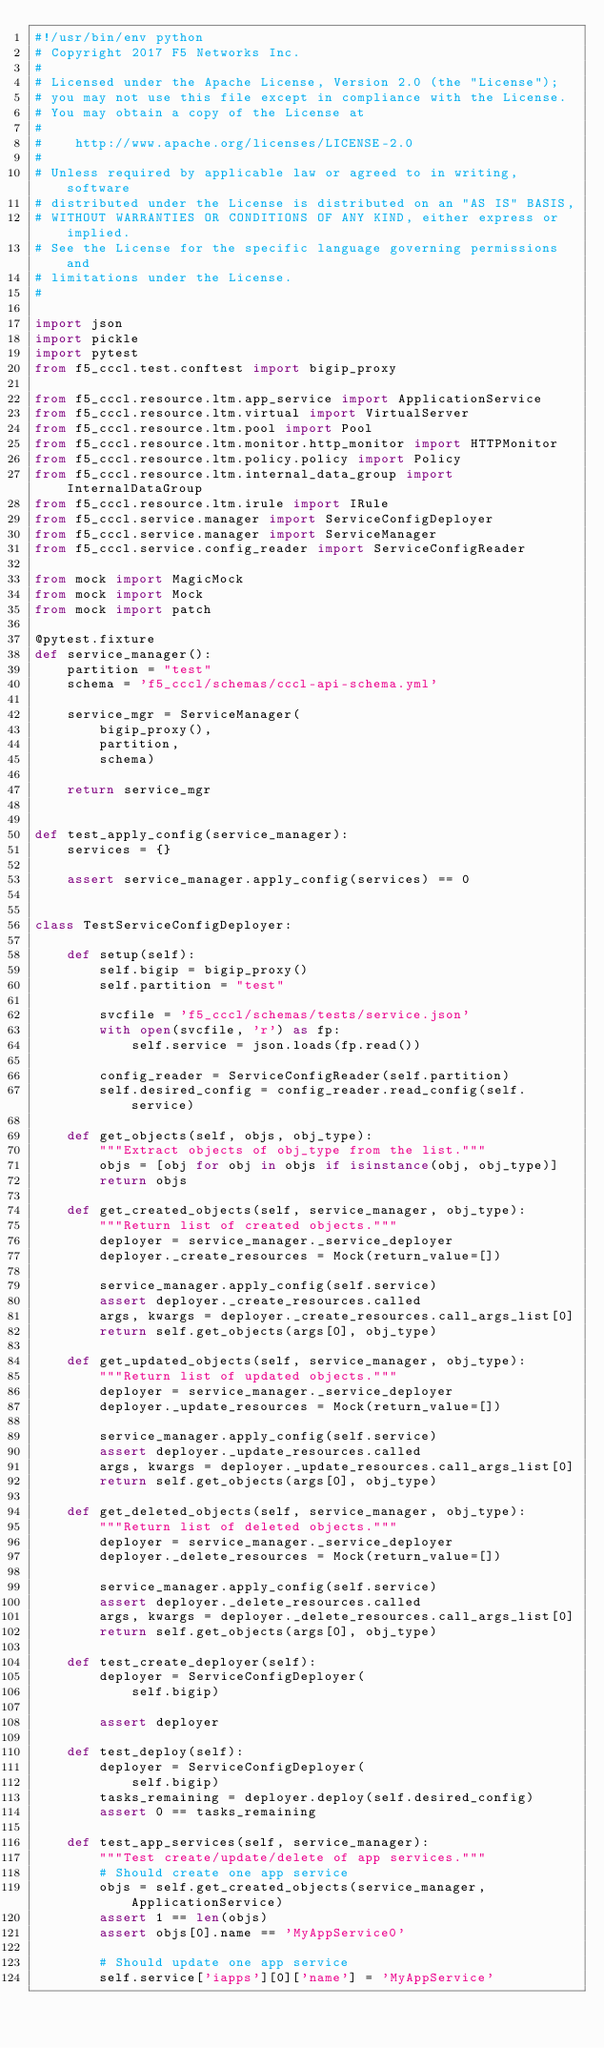Convert code to text. <code><loc_0><loc_0><loc_500><loc_500><_Python_>#!/usr/bin/env python
# Copyright 2017 F5 Networks Inc.
#
# Licensed under the Apache License, Version 2.0 (the "License");
# you may not use this file except in compliance with the License.
# You may obtain a copy of the License at
#
#    http://www.apache.org/licenses/LICENSE-2.0
#
# Unless required by applicable law or agreed to in writing, software
# distributed under the License is distributed on an "AS IS" BASIS,
# WITHOUT WARRANTIES OR CONDITIONS OF ANY KIND, either express or implied.
# See the License for the specific language governing permissions and
# limitations under the License.
#

import json
import pickle
import pytest
from f5_cccl.test.conftest import bigip_proxy

from f5_cccl.resource.ltm.app_service import ApplicationService 
from f5_cccl.resource.ltm.virtual import VirtualServer 
from f5_cccl.resource.ltm.pool import Pool 
from f5_cccl.resource.ltm.monitor.http_monitor import HTTPMonitor 
from f5_cccl.resource.ltm.policy.policy import Policy 
from f5_cccl.resource.ltm.internal_data_group import InternalDataGroup
from f5_cccl.resource.ltm.irule import IRule
from f5_cccl.service.manager import ServiceConfigDeployer
from f5_cccl.service.manager import ServiceManager
from f5_cccl.service.config_reader import ServiceConfigReader

from mock import MagicMock
from mock import Mock
from mock import patch

@pytest.fixture
def service_manager():
    partition = "test"
    schema = 'f5_cccl/schemas/cccl-api-schema.yml'

    service_mgr = ServiceManager(
        bigip_proxy(),
        partition,
        schema)

    return service_mgr


def test_apply_config(service_manager):
    services = {}

    assert service_manager.apply_config(services) == 0


class TestServiceConfigDeployer:

    def setup(self):
        self.bigip = bigip_proxy()
        self.partition = "test"

        svcfile = 'f5_cccl/schemas/tests/service.json'
        with open(svcfile, 'r') as fp:
            self.service = json.loads(fp.read())

        config_reader = ServiceConfigReader(self.partition)
        self.desired_config = config_reader.read_config(self.service)

    def get_objects(self, objs, obj_type):
        """Extract objects of obj_type from the list."""
        objs = [obj for obj in objs if isinstance(obj, obj_type)]
        return objs

    def get_created_objects(self, service_manager, obj_type):
        """Return list of created objects."""
        deployer = service_manager._service_deployer
        deployer._create_resources = Mock(return_value=[])

        service_manager.apply_config(self.service)
        assert deployer._create_resources.called
        args, kwargs = deployer._create_resources.call_args_list[0]
        return self.get_objects(args[0], obj_type) 

    def get_updated_objects(self, service_manager, obj_type):
        """Return list of updated objects."""
        deployer = service_manager._service_deployer
        deployer._update_resources = Mock(return_value=[])

        service_manager.apply_config(self.service)
        assert deployer._update_resources.called
        args, kwargs = deployer._update_resources.call_args_list[0]
        return self.get_objects(args[0], obj_type) 

    def get_deleted_objects(self, service_manager, obj_type):
        """Return list of deleted objects."""
        deployer = service_manager._service_deployer
        deployer._delete_resources = Mock(return_value=[])

        service_manager.apply_config(self.service)
        assert deployer._delete_resources.called
        args, kwargs = deployer._delete_resources.call_args_list[0]
        return self.get_objects(args[0], obj_type) 

    def test_create_deployer(self):
        deployer = ServiceConfigDeployer(
            self.bigip)

        assert deployer

    def test_deploy(self):
        deployer = ServiceConfigDeployer(
            self.bigip)
        tasks_remaining = deployer.deploy(self.desired_config)
        assert 0 == tasks_remaining

    def test_app_services(self, service_manager):
        """Test create/update/delete of app services."""
        # Should create one app service
        objs = self.get_created_objects(service_manager, ApplicationService)
        assert 1 == len(objs)
        assert objs[0].name == 'MyAppService0'

        # Should update one app service
        self.service['iapps'][0]['name'] = 'MyAppService'</code> 